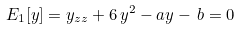Convert formula to latex. <formula><loc_0><loc_0><loc_500><loc_500>E _ { 1 } [ y ] = y _ { z z } + 6 \, y ^ { 2 } - a y - \, { b } = 0</formula> 